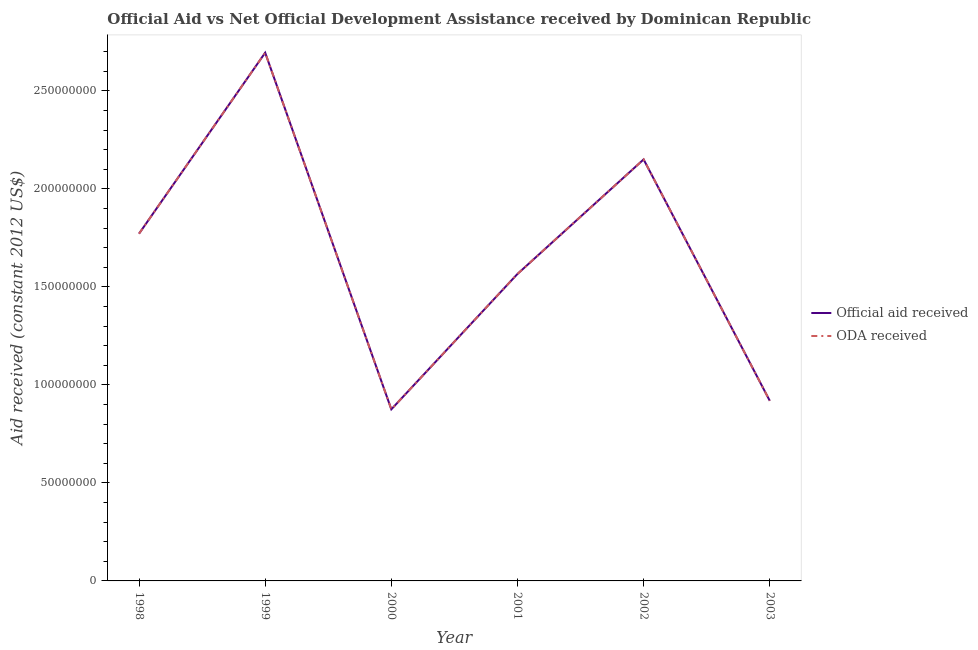How many different coloured lines are there?
Your response must be concise. 2. Is the number of lines equal to the number of legend labels?
Give a very brief answer. Yes. What is the oda received in 2001?
Offer a terse response. 1.57e+08. Across all years, what is the maximum official aid received?
Offer a very short reply. 2.69e+08. Across all years, what is the minimum oda received?
Your response must be concise. 8.75e+07. What is the total oda received in the graph?
Give a very brief answer. 9.98e+08. What is the difference between the official aid received in 2001 and that in 2003?
Your answer should be very brief. 6.47e+07. What is the difference between the official aid received in 2002 and the oda received in 2000?
Make the answer very short. 1.27e+08. What is the average oda received per year?
Provide a short and direct response. 1.66e+08. In how many years, is the oda received greater than 250000000 US$?
Your answer should be compact. 1. What is the ratio of the oda received in 2002 to that in 2003?
Provide a short and direct response. 2.34. Is the difference between the oda received in 1999 and 2001 greater than the difference between the official aid received in 1999 and 2001?
Provide a succinct answer. No. What is the difference between the highest and the second highest official aid received?
Your answer should be compact. 5.44e+07. What is the difference between the highest and the lowest official aid received?
Provide a short and direct response. 1.82e+08. Is the oda received strictly less than the official aid received over the years?
Your answer should be compact. No. How many years are there in the graph?
Your answer should be compact. 6. Are the values on the major ticks of Y-axis written in scientific E-notation?
Your answer should be very brief. No. Does the graph contain grids?
Give a very brief answer. No. Where does the legend appear in the graph?
Offer a terse response. Center right. How are the legend labels stacked?
Provide a short and direct response. Vertical. What is the title of the graph?
Provide a short and direct response. Official Aid vs Net Official Development Assistance received by Dominican Republic . What is the label or title of the Y-axis?
Ensure brevity in your answer.  Aid received (constant 2012 US$). What is the Aid received (constant 2012 US$) of Official aid received in 1998?
Keep it short and to the point. 1.77e+08. What is the Aid received (constant 2012 US$) in ODA received in 1998?
Give a very brief answer. 1.77e+08. What is the Aid received (constant 2012 US$) of Official aid received in 1999?
Offer a terse response. 2.69e+08. What is the Aid received (constant 2012 US$) of ODA received in 1999?
Give a very brief answer. 2.69e+08. What is the Aid received (constant 2012 US$) in Official aid received in 2000?
Provide a succinct answer. 8.75e+07. What is the Aid received (constant 2012 US$) of ODA received in 2000?
Provide a short and direct response. 8.75e+07. What is the Aid received (constant 2012 US$) in Official aid received in 2001?
Ensure brevity in your answer.  1.57e+08. What is the Aid received (constant 2012 US$) of ODA received in 2001?
Your answer should be very brief. 1.57e+08. What is the Aid received (constant 2012 US$) in Official aid received in 2002?
Offer a terse response. 2.15e+08. What is the Aid received (constant 2012 US$) in ODA received in 2002?
Make the answer very short. 2.15e+08. What is the Aid received (constant 2012 US$) in Official aid received in 2003?
Your answer should be compact. 9.19e+07. What is the Aid received (constant 2012 US$) in ODA received in 2003?
Offer a very short reply. 9.19e+07. Across all years, what is the maximum Aid received (constant 2012 US$) in Official aid received?
Your response must be concise. 2.69e+08. Across all years, what is the maximum Aid received (constant 2012 US$) of ODA received?
Your answer should be very brief. 2.69e+08. Across all years, what is the minimum Aid received (constant 2012 US$) of Official aid received?
Offer a terse response. 8.75e+07. Across all years, what is the minimum Aid received (constant 2012 US$) in ODA received?
Provide a succinct answer. 8.75e+07. What is the total Aid received (constant 2012 US$) of Official aid received in the graph?
Provide a succinct answer. 9.98e+08. What is the total Aid received (constant 2012 US$) in ODA received in the graph?
Make the answer very short. 9.98e+08. What is the difference between the Aid received (constant 2012 US$) of Official aid received in 1998 and that in 1999?
Your answer should be compact. -9.23e+07. What is the difference between the Aid received (constant 2012 US$) of ODA received in 1998 and that in 1999?
Provide a succinct answer. -9.23e+07. What is the difference between the Aid received (constant 2012 US$) of Official aid received in 1998 and that in 2000?
Ensure brevity in your answer.  8.96e+07. What is the difference between the Aid received (constant 2012 US$) in ODA received in 1998 and that in 2000?
Offer a very short reply. 8.96e+07. What is the difference between the Aid received (constant 2012 US$) of Official aid received in 1998 and that in 2001?
Offer a terse response. 2.05e+07. What is the difference between the Aid received (constant 2012 US$) of ODA received in 1998 and that in 2001?
Your answer should be very brief. 2.05e+07. What is the difference between the Aid received (constant 2012 US$) in Official aid received in 1998 and that in 2002?
Your answer should be compact. -3.79e+07. What is the difference between the Aid received (constant 2012 US$) of ODA received in 1998 and that in 2002?
Your response must be concise. -3.79e+07. What is the difference between the Aid received (constant 2012 US$) in Official aid received in 1998 and that in 2003?
Ensure brevity in your answer.  8.52e+07. What is the difference between the Aid received (constant 2012 US$) of ODA received in 1998 and that in 2003?
Give a very brief answer. 8.52e+07. What is the difference between the Aid received (constant 2012 US$) of Official aid received in 1999 and that in 2000?
Provide a short and direct response. 1.82e+08. What is the difference between the Aid received (constant 2012 US$) in ODA received in 1999 and that in 2000?
Your answer should be very brief. 1.82e+08. What is the difference between the Aid received (constant 2012 US$) of Official aid received in 1999 and that in 2001?
Provide a succinct answer. 1.13e+08. What is the difference between the Aid received (constant 2012 US$) of ODA received in 1999 and that in 2001?
Offer a very short reply. 1.13e+08. What is the difference between the Aid received (constant 2012 US$) of Official aid received in 1999 and that in 2002?
Provide a short and direct response. 5.44e+07. What is the difference between the Aid received (constant 2012 US$) in ODA received in 1999 and that in 2002?
Your answer should be very brief. 5.44e+07. What is the difference between the Aid received (constant 2012 US$) in Official aid received in 1999 and that in 2003?
Offer a very short reply. 1.78e+08. What is the difference between the Aid received (constant 2012 US$) in ODA received in 1999 and that in 2003?
Your answer should be compact. 1.78e+08. What is the difference between the Aid received (constant 2012 US$) of Official aid received in 2000 and that in 2001?
Keep it short and to the point. -6.90e+07. What is the difference between the Aid received (constant 2012 US$) in ODA received in 2000 and that in 2001?
Your response must be concise. -6.90e+07. What is the difference between the Aid received (constant 2012 US$) in Official aid received in 2000 and that in 2002?
Offer a very short reply. -1.27e+08. What is the difference between the Aid received (constant 2012 US$) in ODA received in 2000 and that in 2002?
Keep it short and to the point. -1.27e+08. What is the difference between the Aid received (constant 2012 US$) of Official aid received in 2000 and that in 2003?
Provide a short and direct response. -4.35e+06. What is the difference between the Aid received (constant 2012 US$) of ODA received in 2000 and that in 2003?
Give a very brief answer. -4.35e+06. What is the difference between the Aid received (constant 2012 US$) in Official aid received in 2001 and that in 2002?
Provide a succinct answer. -5.84e+07. What is the difference between the Aid received (constant 2012 US$) of ODA received in 2001 and that in 2002?
Make the answer very short. -5.84e+07. What is the difference between the Aid received (constant 2012 US$) of Official aid received in 2001 and that in 2003?
Your answer should be very brief. 6.47e+07. What is the difference between the Aid received (constant 2012 US$) in ODA received in 2001 and that in 2003?
Offer a very short reply. 6.47e+07. What is the difference between the Aid received (constant 2012 US$) of Official aid received in 2002 and that in 2003?
Offer a terse response. 1.23e+08. What is the difference between the Aid received (constant 2012 US$) in ODA received in 2002 and that in 2003?
Keep it short and to the point. 1.23e+08. What is the difference between the Aid received (constant 2012 US$) of Official aid received in 1998 and the Aid received (constant 2012 US$) of ODA received in 1999?
Make the answer very short. -9.23e+07. What is the difference between the Aid received (constant 2012 US$) of Official aid received in 1998 and the Aid received (constant 2012 US$) of ODA received in 2000?
Provide a succinct answer. 8.96e+07. What is the difference between the Aid received (constant 2012 US$) of Official aid received in 1998 and the Aid received (constant 2012 US$) of ODA received in 2001?
Provide a short and direct response. 2.05e+07. What is the difference between the Aid received (constant 2012 US$) of Official aid received in 1998 and the Aid received (constant 2012 US$) of ODA received in 2002?
Your answer should be very brief. -3.79e+07. What is the difference between the Aid received (constant 2012 US$) in Official aid received in 1998 and the Aid received (constant 2012 US$) in ODA received in 2003?
Provide a short and direct response. 8.52e+07. What is the difference between the Aid received (constant 2012 US$) of Official aid received in 1999 and the Aid received (constant 2012 US$) of ODA received in 2000?
Give a very brief answer. 1.82e+08. What is the difference between the Aid received (constant 2012 US$) in Official aid received in 1999 and the Aid received (constant 2012 US$) in ODA received in 2001?
Provide a short and direct response. 1.13e+08. What is the difference between the Aid received (constant 2012 US$) of Official aid received in 1999 and the Aid received (constant 2012 US$) of ODA received in 2002?
Offer a terse response. 5.44e+07. What is the difference between the Aid received (constant 2012 US$) in Official aid received in 1999 and the Aid received (constant 2012 US$) in ODA received in 2003?
Ensure brevity in your answer.  1.78e+08. What is the difference between the Aid received (constant 2012 US$) in Official aid received in 2000 and the Aid received (constant 2012 US$) in ODA received in 2001?
Provide a short and direct response. -6.90e+07. What is the difference between the Aid received (constant 2012 US$) of Official aid received in 2000 and the Aid received (constant 2012 US$) of ODA received in 2002?
Give a very brief answer. -1.27e+08. What is the difference between the Aid received (constant 2012 US$) in Official aid received in 2000 and the Aid received (constant 2012 US$) in ODA received in 2003?
Your answer should be very brief. -4.35e+06. What is the difference between the Aid received (constant 2012 US$) of Official aid received in 2001 and the Aid received (constant 2012 US$) of ODA received in 2002?
Your response must be concise. -5.84e+07. What is the difference between the Aid received (constant 2012 US$) in Official aid received in 2001 and the Aid received (constant 2012 US$) in ODA received in 2003?
Offer a terse response. 6.47e+07. What is the difference between the Aid received (constant 2012 US$) in Official aid received in 2002 and the Aid received (constant 2012 US$) in ODA received in 2003?
Give a very brief answer. 1.23e+08. What is the average Aid received (constant 2012 US$) of Official aid received per year?
Keep it short and to the point. 1.66e+08. What is the average Aid received (constant 2012 US$) of ODA received per year?
Your response must be concise. 1.66e+08. In the year 2001, what is the difference between the Aid received (constant 2012 US$) in Official aid received and Aid received (constant 2012 US$) in ODA received?
Keep it short and to the point. 0. In the year 2002, what is the difference between the Aid received (constant 2012 US$) in Official aid received and Aid received (constant 2012 US$) in ODA received?
Your answer should be compact. 0. In the year 2003, what is the difference between the Aid received (constant 2012 US$) of Official aid received and Aid received (constant 2012 US$) of ODA received?
Provide a succinct answer. 0. What is the ratio of the Aid received (constant 2012 US$) of Official aid received in 1998 to that in 1999?
Keep it short and to the point. 0.66. What is the ratio of the Aid received (constant 2012 US$) of ODA received in 1998 to that in 1999?
Provide a succinct answer. 0.66. What is the ratio of the Aid received (constant 2012 US$) in Official aid received in 1998 to that in 2000?
Your response must be concise. 2.02. What is the ratio of the Aid received (constant 2012 US$) in ODA received in 1998 to that in 2000?
Offer a very short reply. 2.02. What is the ratio of the Aid received (constant 2012 US$) in Official aid received in 1998 to that in 2001?
Make the answer very short. 1.13. What is the ratio of the Aid received (constant 2012 US$) in ODA received in 1998 to that in 2001?
Keep it short and to the point. 1.13. What is the ratio of the Aid received (constant 2012 US$) in Official aid received in 1998 to that in 2002?
Make the answer very short. 0.82. What is the ratio of the Aid received (constant 2012 US$) of ODA received in 1998 to that in 2002?
Keep it short and to the point. 0.82. What is the ratio of the Aid received (constant 2012 US$) of Official aid received in 1998 to that in 2003?
Your response must be concise. 1.93. What is the ratio of the Aid received (constant 2012 US$) of ODA received in 1998 to that in 2003?
Offer a very short reply. 1.93. What is the ratio of the Aid received (constant 2012 US$) of Official aid received in 1999 to that in 2000?
Your answer should be very brief. 3.08. What is the ratio of the Aid received (constant 2012 US$) of ODA received in 1999 to that in 2000?
Keep it short and to the point. 3.08. What is the ratio of the Aid received (constant 2012 US$) in Official aid received in 1999 to that in 2001?
Your response must be concise. 1.72. What is the ratio of the Aid received (constant 2012 US$) in ODA received in 1999 to that in 2001?
Make the answer very short. 1.72. What is the ratio of the Aid received (constant 2012 US$) of Official aid received in 1999 to that in 2002?
Ensure brevity in your answer.  1.25. What is the ratio of the Aid received (constant 2012 US$) of ODA received in 1999 to that in 2002?
Your answer should be compact. 1.25. What is the ratio of the Aid received (constant 2012 US$) in Official aid received in 1999 to that in 2003?
Keep it short and to the point. 2.93. What is the ratio of the Aid received (constant 2012 US$) of ODA received in 1999 to that in 2003?
Offer a terse response. 2.93. What is the ratio of the Aid received (constant 2012 US$) in Official aid received in 2000 to that in 2001?
Ensure brevity in your answer.  0.56. What is the ratio of the Aid received (constant 2012 US$) in ODA received in 2000 to that in 2001?
Provide a succinct answer. 0.56. What is the ratio of the Aid received (constant 2012 US$) in Official aid received in 2000 to that in 2002?
Your response must be concise. 0.41. What is the ratio of the Aid received (constant 2012 US$) of ODA received in 2000 to that in 2002?
Give a very brief answer. 0.41. What is the ratio of the Aid received (constant 2012 US$) of Official aid received in 2000 to that in 2003?
Keep it short and to the point. 0.95. What is the ratio of the Aid received (constant 2012 US$) of ODA received in 2000 to that in 2003?
Your answer should be very brief. 0.95. What is the ratio of the Aid received (constant 2012 US$) in Official aid received in 2001 to that in 2002?
Your answer should be very brief. 0.73. What is the ratio of the Aid received (constant 2012 US$) of ODA received in 2001 to that in 2002?
Your response must be concise. 0.73. What is the ratio of the Aid received (constant 2012 US$) in Official aid received in 2001 to that in 2003?
Provide a short and direct response. 1.7. What is the ratio of the Aid received (constant 2012 US$) in ODA received in 2001 to that in 2003?
Your response must be concise. 1.7. What is the ratio of the Aid received (constant 2012 US$) in Official aid received in 2002 to that in 2003?
Your answer should be very brief. 2.34. What is the ratio of the Aid received (constant 2012 US$) of ODA received in 2002 to that in 2003?
Offer a very short reply. 2.34. What is the difference between the highest and the second highest Aid received (constant 2012 US$) of Official aid received?
Ensure brevity in your answer.  5.44e+07. What is the difference between the highest and the second highest Aid received (constant 2012 US$) in ODA received?
Your answer should be very brief. 5.44e+07. What is the difference between the highest and the lowest Aid received (constant 2012 US$) in Official aid received?
Offer a terse response. 1.82e+08. What is the difference between the highest and the lowest Aid received (constant 2012 US$) in ODA received?
Offer a very short reply. 1.82e+08. 